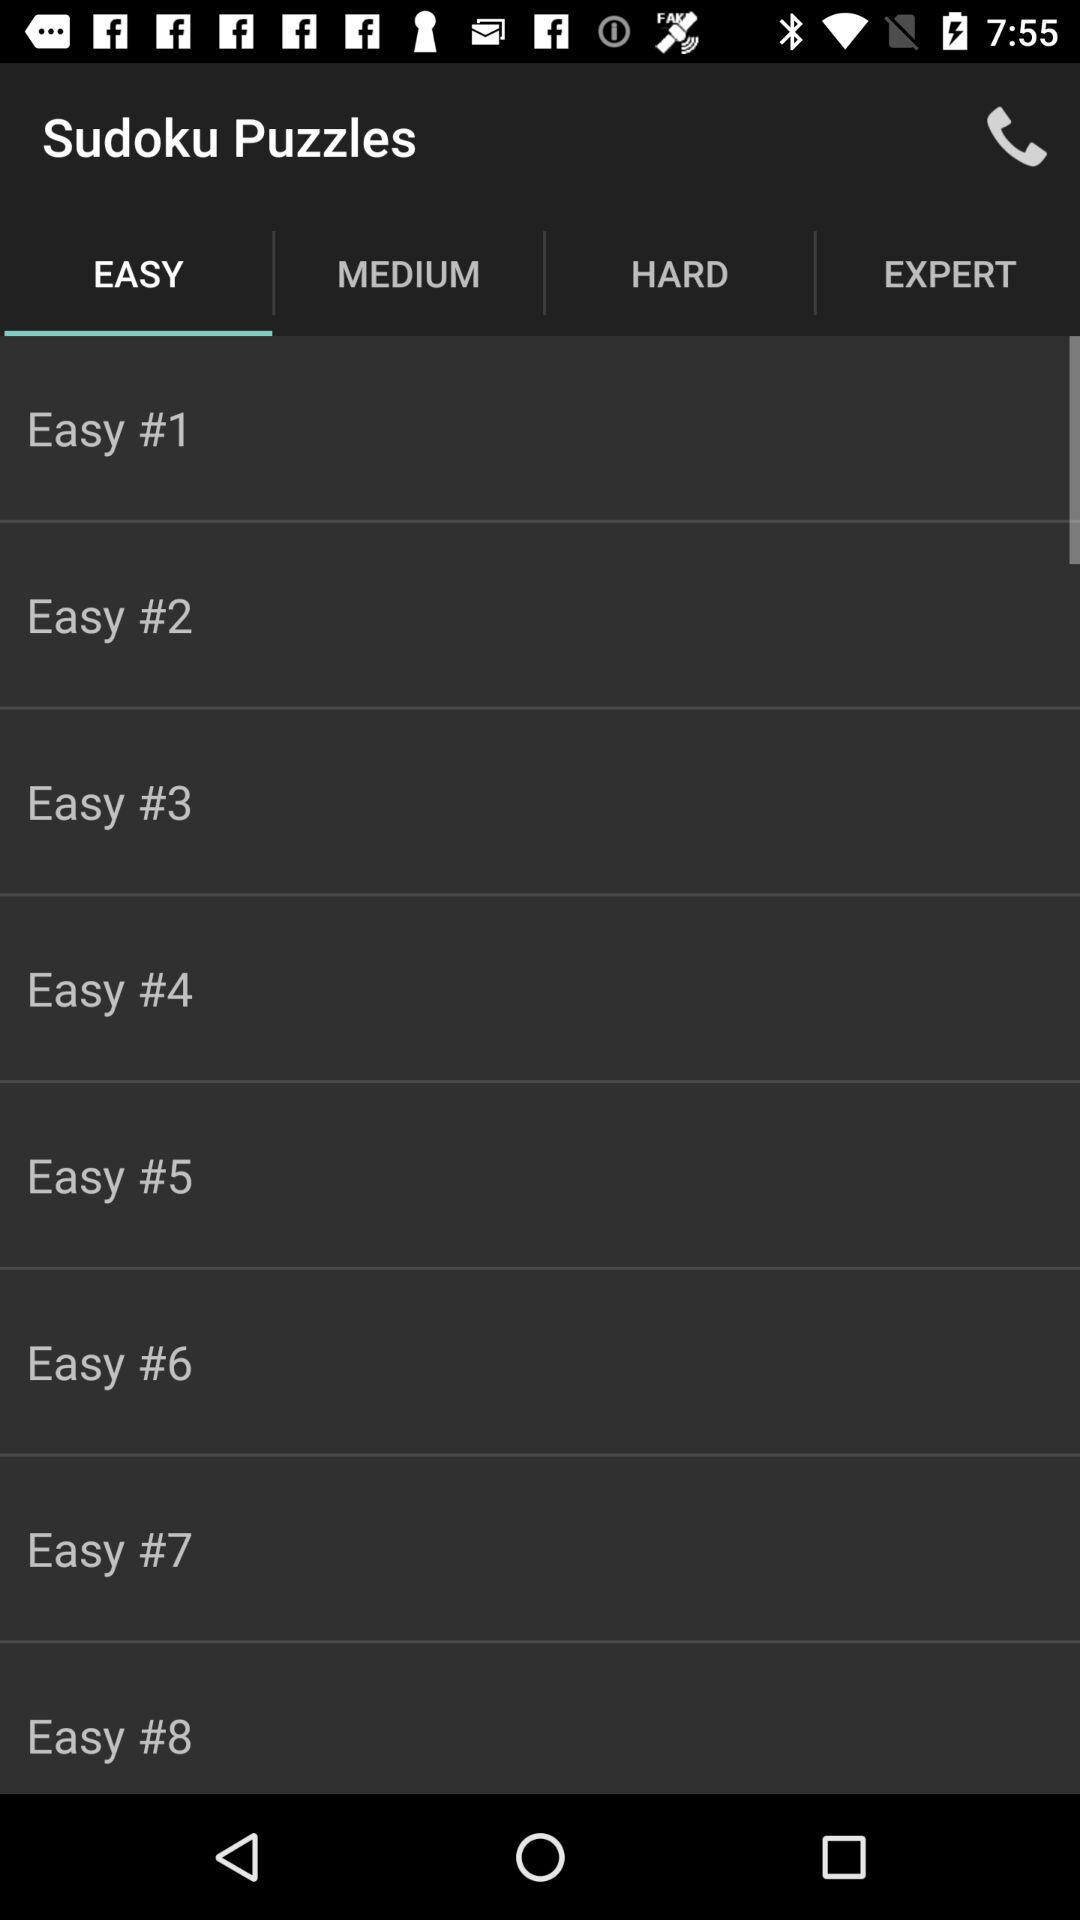How many puzzles are there in total?
Answer the question using a single word or phrase. 8 